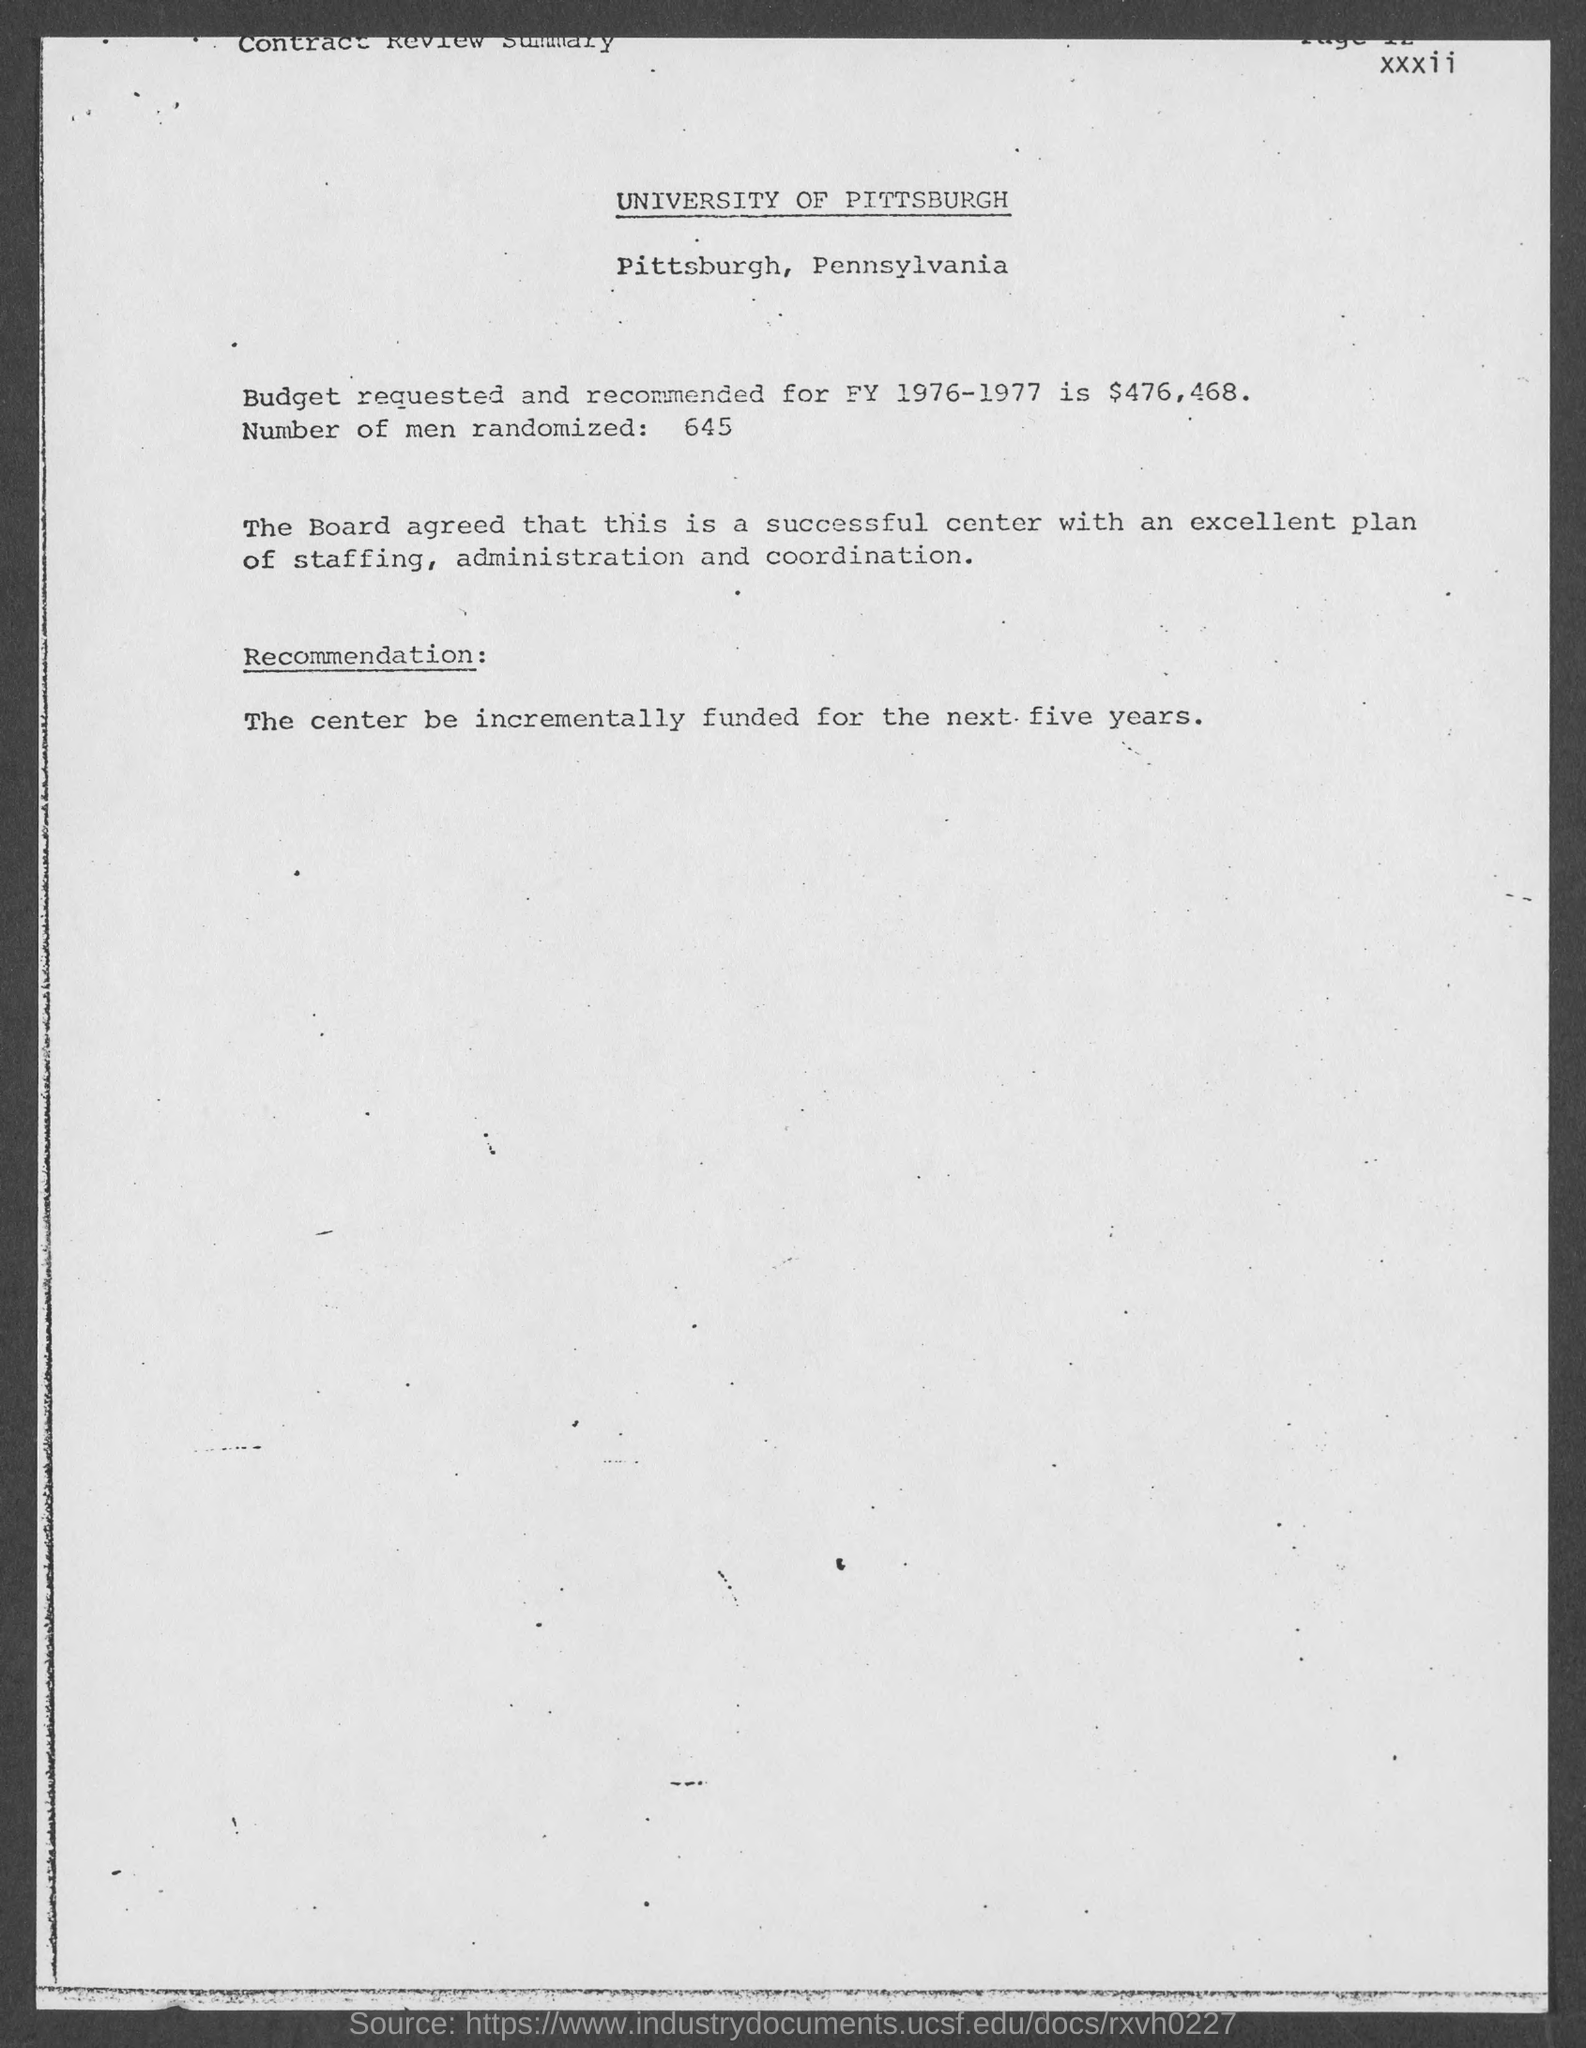What is the budget requested and recommended for fy 1976-1977 ?
Provide a succinct answer. $476,468. How many number of men are randomized ?
Your answer should be very brief. 645. 